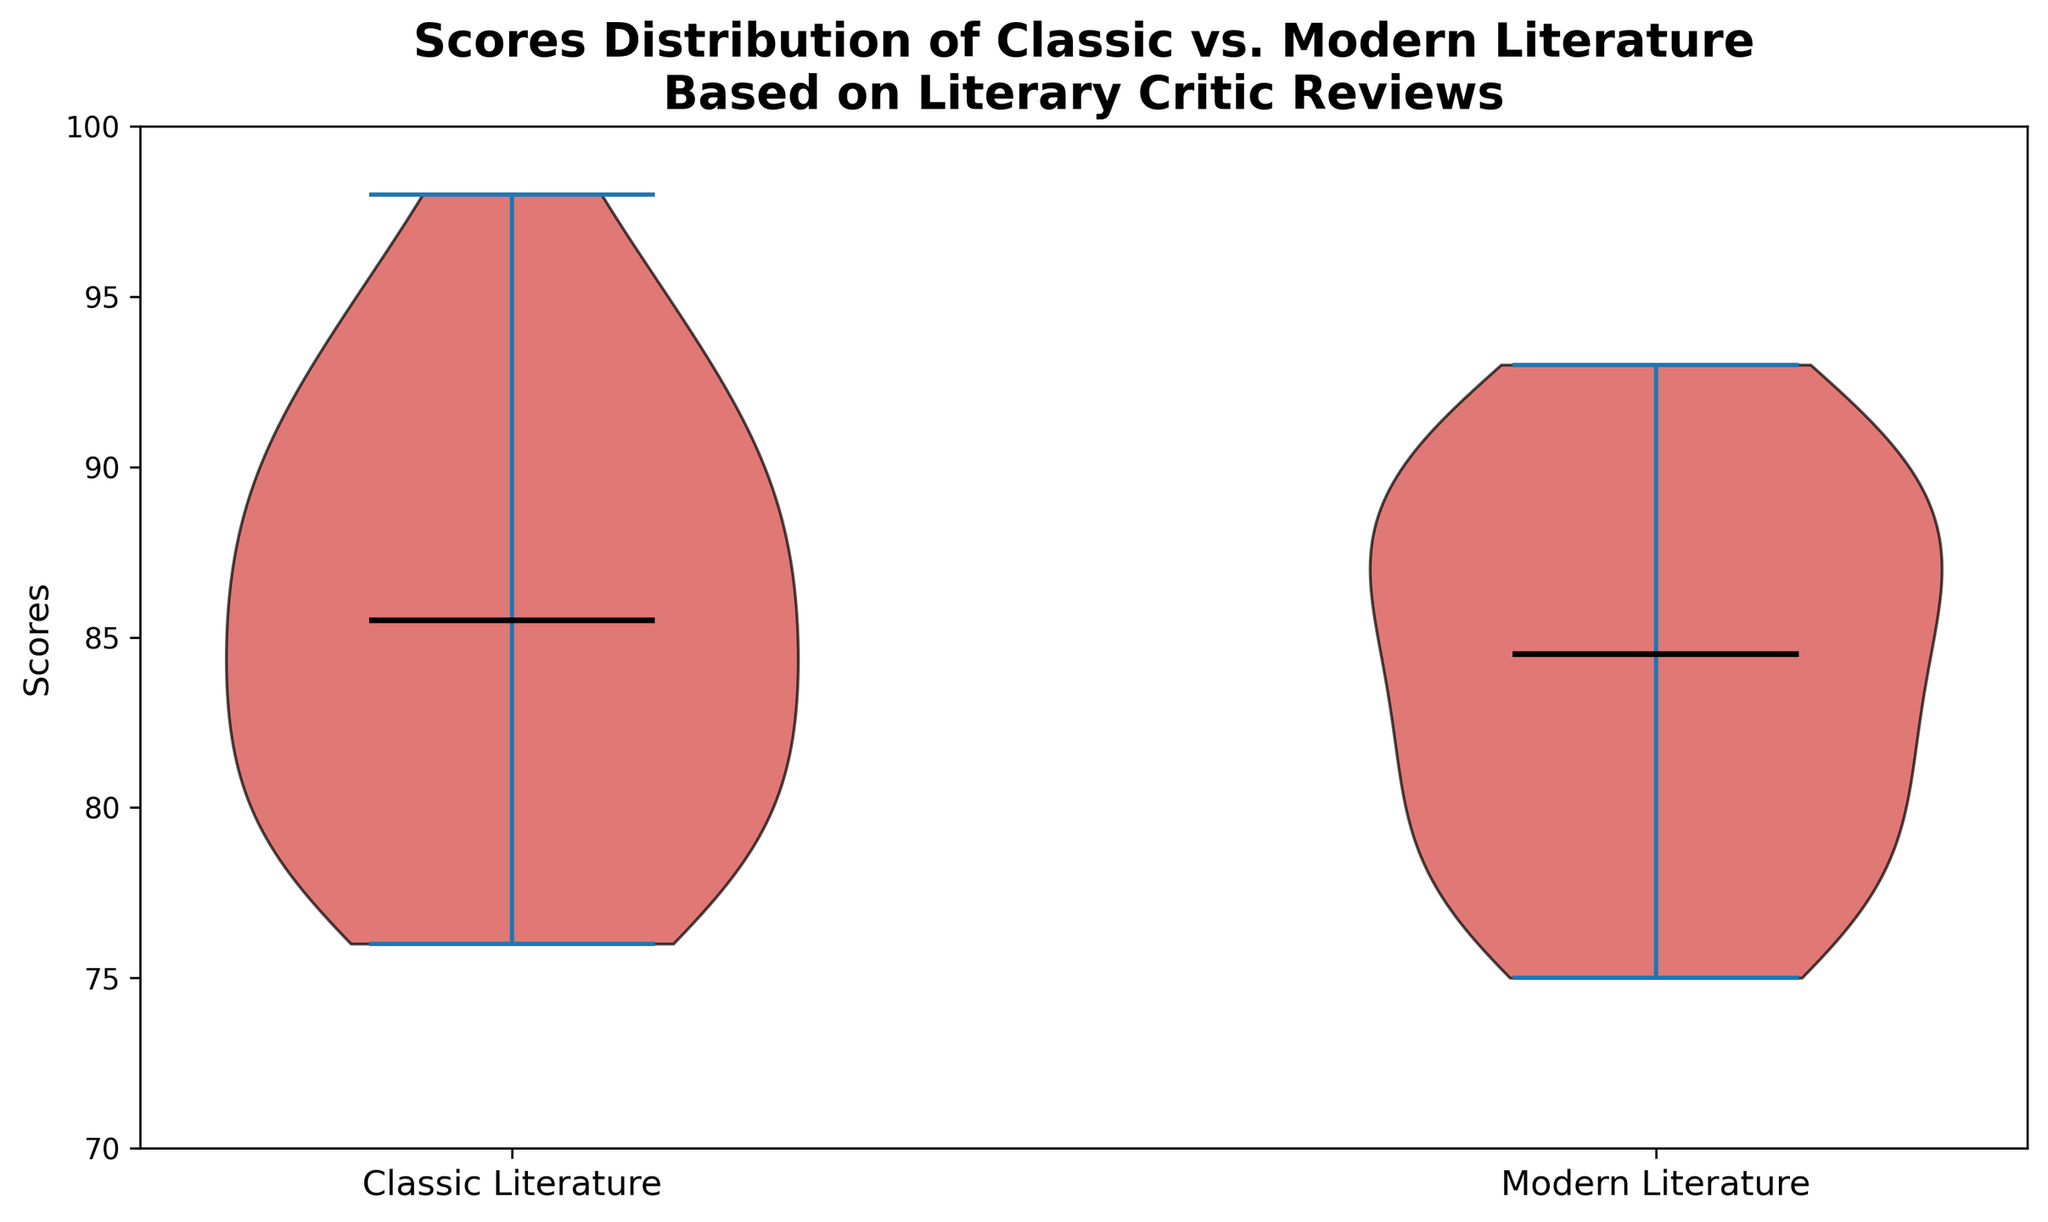How do the median scores of Classic Literature and Modern Literature compare? The violin plot shows the median lines for both distributions. The median line for Classic Literature is slightly higher than Modern Literature, indicating that Classic Literature has a higher median score.
Answer: Classic Literature has a higher median score Which category has a wider range of scores according to the plot? The spread of scores (length of the violins) indicates the range. Classic Literature's violin appears to be slightly longer, which suggests a wider range of scores compared to Modern Literature.
Answer: Classic Literature What is the approximate lowest score observed for Modern Literature? Look at the bottom end of the Modern Literature violin. The lowest point represents the lowest score. It is around 75.
Answer: 75 Which category appears to have more outliers, or extreme values, towards the high end of the score spectrum? The visualization of the violin plot shows the density and position of the scores. Classic Literature appears to have more density towards the higher scores, suggesting more outliers at the high end.
Answer: Classic Literature Is the overall distribution of scores for both categories relatively symmetric? Symmetry in the violin plot is indicated by mirrored shape around the median. Both categories, Classic and Modern Literature, seem relatively symmetric around their medians, though Modern Literature appears a little less symmetric.
Answer: Yes, relatively symmetric Do any of the categories have a score distribution that is bimodal? Bimodal distributions have two distinct peaks. The violin plot shows a single peak for both Classic and Modern Literature, indicating neither has a bimodal distribution.
Answer: No What is the approximate highest score observed for Classic Literature? The top end of the Classic Literature violin plot represents the highest score. The highest point is around 98.
Answer: 98 Between Classic and Modern Literature, which one has a higher median and lower overall spread of scores? Classic Literature has a slightly higher median, but also seems to have a wider spread. Modern Literature has a slightly lower median with a narrower spread as indicated by the width of the violin.
Answer: Modern Literature has a lower spread, Classic Literature has a higher median 